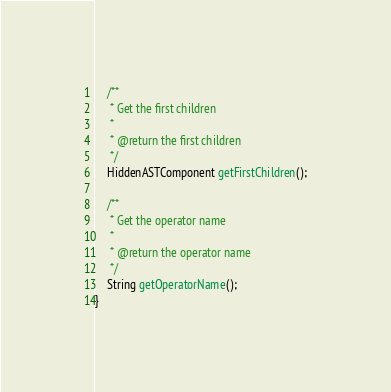Convert code to text. <code><loc_0><loc_0><loc_500><loc_500><_Java_>
    /**
     * Get the first children
     *
     * @return the first children
     */
    HiddenASTComponent getFirstChildren();

    /**
     * Get the operator name
     *
     * @return the operator name
     */
    String getOperatorName();
}
</code> 